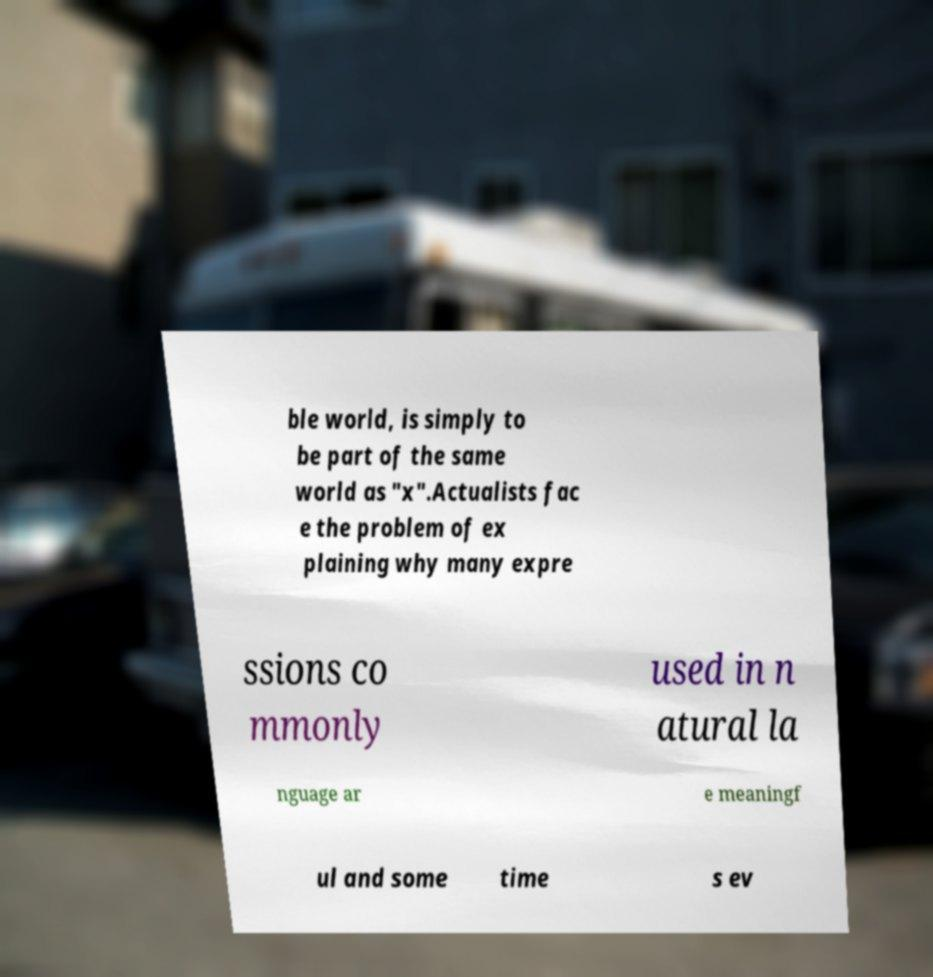There's text embedded in this image that I need extracted. Can you transcribe it verbatim? ble world, is simply to be part of the same world as "x".Actualists fac e the problem of ex plaining why many expre ssions co mmonly used in n atural la nguage ar e meaningf ul and some time s ev 